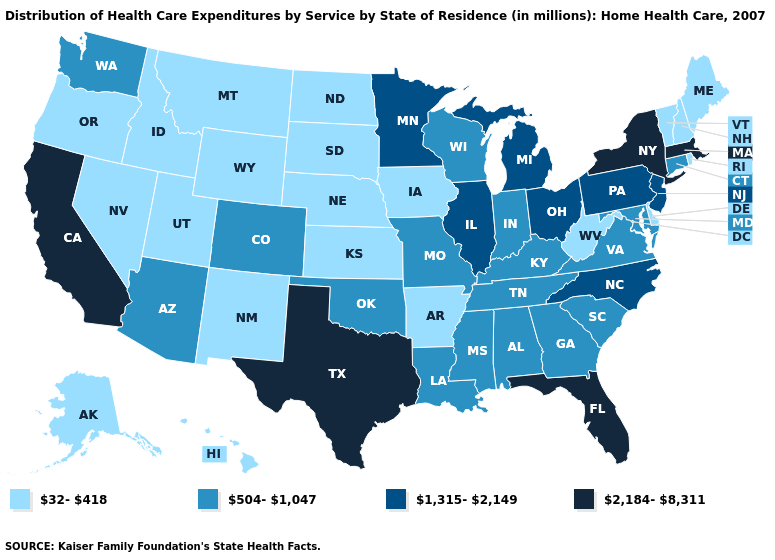Name the states that have a value in the range 1,315-2,149?
Keep it brief. Illinois, Michigan, Minnesota, New Jersey, North Carolina, Ohio, Pennsylvania. Among the states that border Oklahoma , which have the lowest value?
Be succinct. Arkansas, Kansas, New Mexico. What is the value of North Dakota?
Answer briefly. 32-418. Name the states that have a value in the range 1,315-2,149?
Be succinct. Illinois, Michigan, Minnesota, New Jersey, North Carolina, Ohio, Pennsylvania. Among the states that border Missouri , does Iowa have the lowest value?
Give a very brief answer. Yes. Does Rhode Island have a lower value than Missouri?
Quick response, please. Yes. Among the states that border Pennsylvania , does New York have the lowest value?
Write a very short answer. No. Among the states that border Indiana , does Kentucky have the highest value?
Short answer required. No. Among the states that border Maryland , which have the highest value?
Keep it brief. Pennsylvania. What is the lowest value in states that border Maine?
Answer briefly. 32-418. What is the value of Tennessee?
Answer briefly. 504-1,047. What is the value of Utah?
Quick response, please. 32-418. Name the states that have a value in the range 1,315-2,149?
Keep it brief. Illinois, Michigan, Minnesota, New Jersey, North Carolina, Ohio, Pennsylvania. Which states have the lowest value in the Northeast?
Write a very short answer. Maine, New Hampshire, Rhode Island, Vermont. 